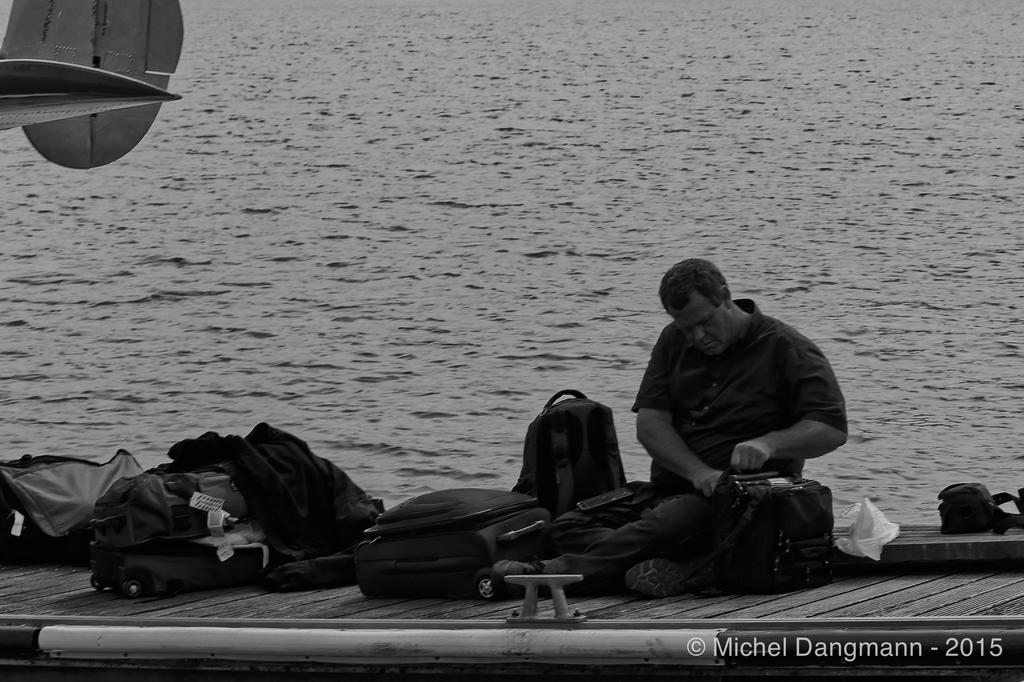Who or what is present in the image? There is a person in the image. What else can be seen in the image besides the person? There are many bags in the image. What can be observed in the background of the image? The background of the image includes water. What type of milk can be seen in the image? There is no milk present in the image. How does the person react to the aftermath of the event in the image? There is no event or aftermath mentioned in the image, so it is not possible to determine the person's reaction. 